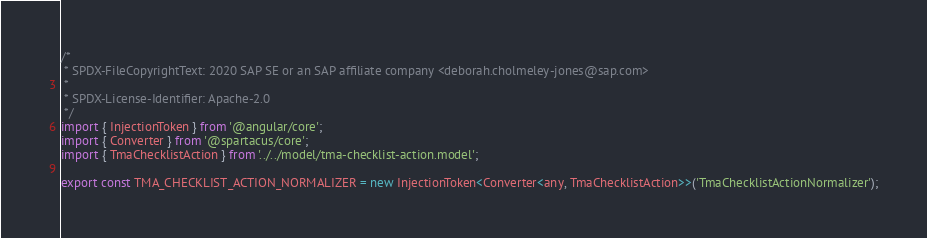Convert code to text. <code><loc_0><loc_0><loc_500><loc_500><_TypeScript_>/*
 * SPDX-FileCopyrightText: 2020 SAP SE or an SAP affiliate company <deborah.cholmeley-jones@sap.com>
 *
 * SPDX-License-Identifier: Apache-2.0
 */
import { InjectionToken } from '@angular/core';
import { Converter } from '@spartacus/core';
import { TmaChecklistAction } from '../../model/tma-checklist-action.model';

export const TMA_CHECKLIST_ACTION_NORMALIZER = new InjectionToken<Converter<any, TmaChecklistAction>>('TmaChecklistActionNormalizer');
</code> 